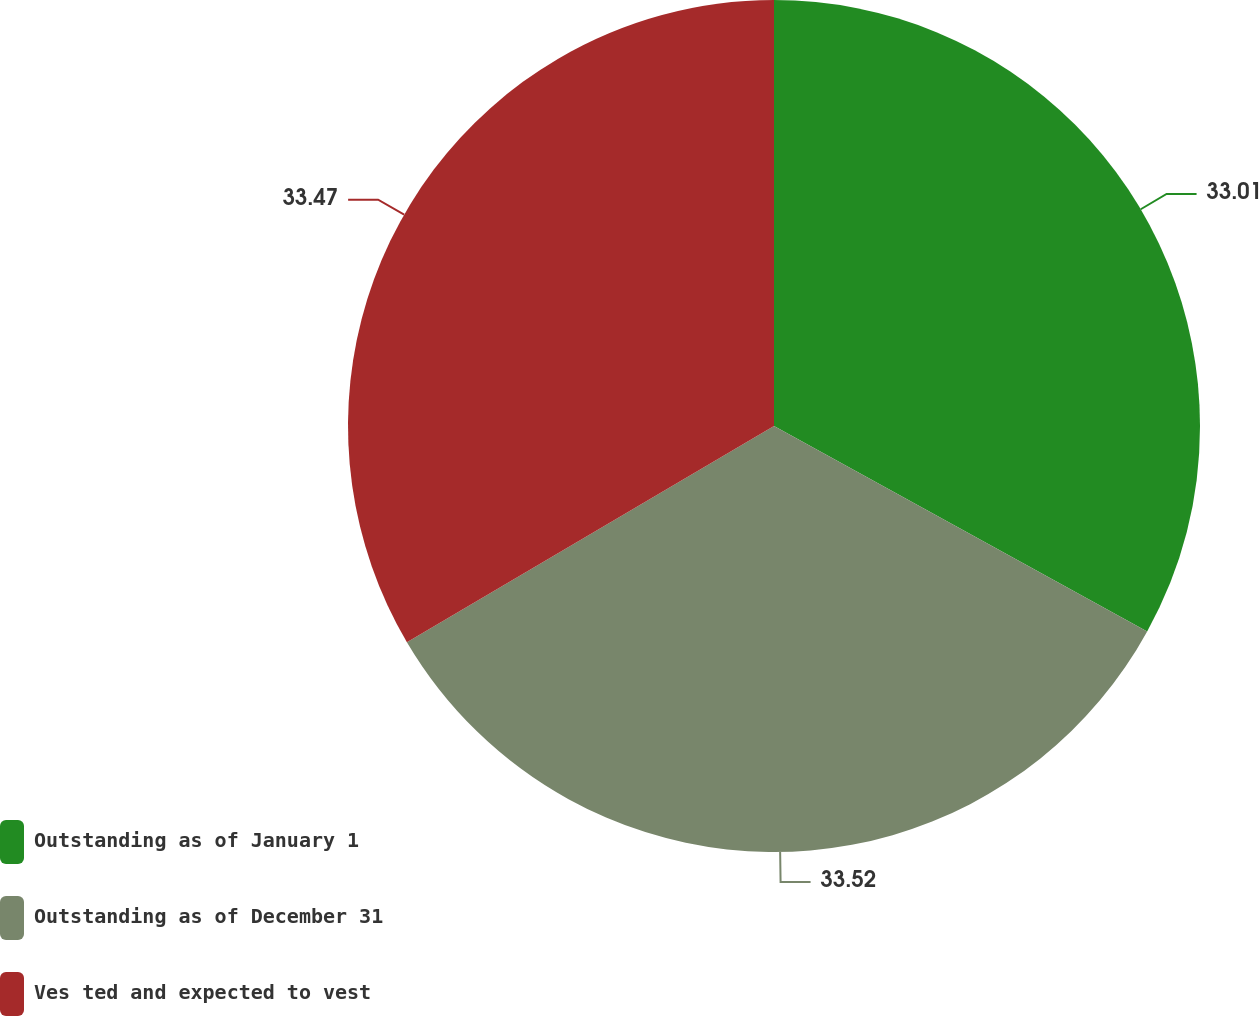Convert chart. <chart><loc_0><loc_0><loc_500><loc_500><pie_chart><fcel>Outstanding as of January 1<fcel>Outstanding as of December 31<fcel>Ves ted and expected to vest<nl><fcel>33.01%<fcel>33.52%<fcel>33.47%<nl></chart> 